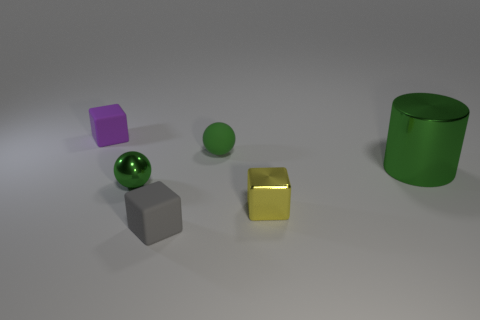How many green spheres must be subtracted to get 1 green spheres? 1 Subtract all matte cubes. How many cubes are left? 1 Add 4 small blue spheres. How many objects exist? 10 Subtract all gray cubes. How many cubes are left? 2 Subtract all cylinders. How many objects are left? 5 Subtract all brown spheres. Subtract all brown cubes. How many spheres are left? 2 Subtract all yellow cubes. Subtract all large green blocks. How many objects are left? 5 Add 3 big green metallic objects. How many big green metallic objects are left? 4 Add 5 green metallic objects. How many green metallic objects exist? 7 Subtract 0 red cylinders. How many objects are left? 6 